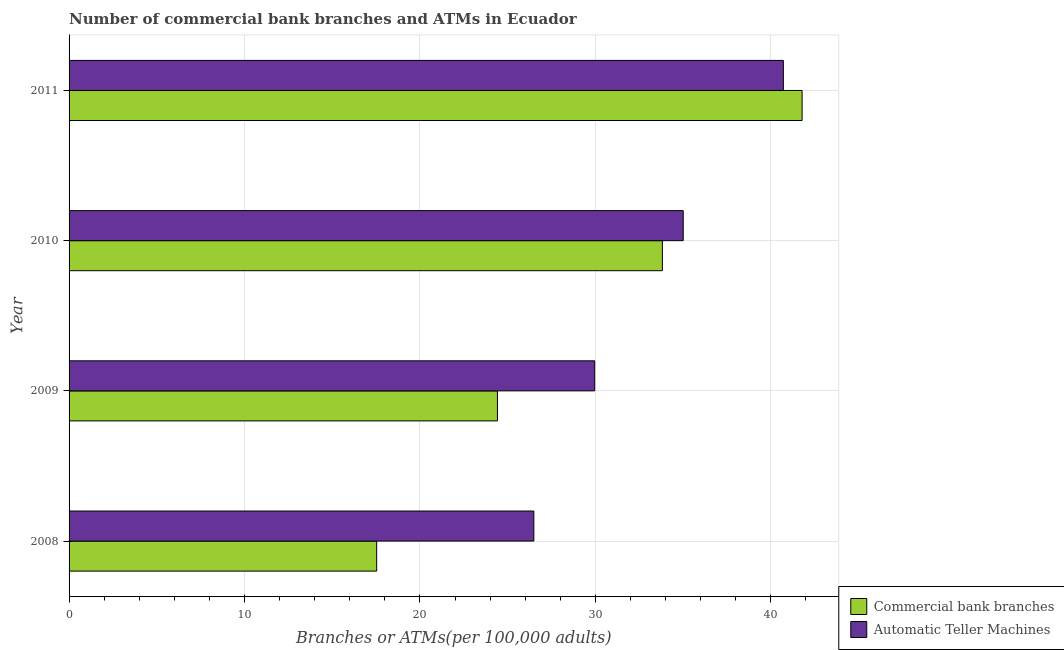How many different coloured bars are there?
Give a very brief answer. 2. How many groups of bars are there?
Provide a succinct answer. 4. Are the number of bars per tick equal to the number of legend labels?
Ensure brevity in your answer.  Yes. Are the number of bars on each tick of the Y-axis equal?
Offer a very short reply. Yes. How many bars are there on the 4th tick from the bottom?
Provide a short and direct response. 2. What is the label of the 1st group of bars from the top?
Provide a short and direct response. 2011. What is the number of atms in 2010?
Your answer should be very brief. 35.01. Across all years, what is the maximum number of atms?
Keep it short and to the point. 40.72. Across all years, what is the minimum number of commercal bank branches?
Keep it short and to the point. 17.53. What is the total number of commercal bank branches in the graph?
Your response must be concise. 117.56. What is the difference between the number of atms in 2009 and that in 2010?
Provide a succinct answer. -5.05. What is the difference between the number of atms in 2010 and the number of commercal bank branches in 2009?
Ensure brevity in your answer.  10.59. What is the average number of commercal bank branches per year?
Provide a short and direct response. 29.39. In the year 2010, what is the difference between the number of atms and number of commercal bank branches?
Your answer should be very brief. 1.19. What is the ratio of the number of atms in 2010 to that in 2011?
Offer a terse response. 0.86. Is the difference between the number of commercal bank branches in 2008 and 2011 greater than the difference between the number of atms in 2008 and 2011?
Your response must be concise. No. What is the difference between the highest and the second highest number of atms?
Your answer should be compact. 5.71. What is the difference between the highest and the lowest number of atms?
Provide a succinct answer. 14.22. In how many years, is the number of commercal bank branches greater than the average number of commercal bank branches taken over all years?
Your answer should be compact. 2. What does the 1st bar from the top in 2010 represents?
Your answer should be compact. Automatic Teller Machines. What does the 2nd bar from the bottom in 2011 represents?
Offer a very short reply. Automatic Teller Machines. How many bars are there?
Give a very brief answer. 8. Are all the bars in the graph horizontal?
Your answer should be compact. Yes. Are the values on the major ticks of X-axis written in scientific E-notation?
Provide a short and direct response. No. How many legend labels are there?
Give a very brief answer. 2. How are the legend labels stacked?
Offer a terse response. Vertical. What is the title of the graph?
Ensure brevity in your answer.  Number of commercial bank branches and ATMs in Ecuador. What is the label or title of the X-axis?
Ensure brevity in your answer.  Branches or ATMs(per 100,0 adults). What is the Branches or ATMs(per 100,000 adults) of Commercial bank branches in 2008?
Give a very brief answer. 17.53. What is the Branches or ATMs(per 100,000 adults) of Automatic Teller Machines in 2008?
Ensure brevity in your answer.  26.49. What is the Branches or ATMs(per 100,000 adults) of Commercial bank branches in 2009?
Provide a succinct answer. 24.42. What is the Branches or ATMs(per 100,000 adults) of Automatic Teller Machines in 2009?
Offer a terse response. 29.96. What is the Branches or ATMs(per 100,000 adults) of Commercial bank branches in 2010?
Your answer should be compact. 33.82. What is the Branches or ATMs(per 100,000 adults) in Automatic Teller Machines in 2010?
Your answer should be very brief. 35.01. What is the Branches or ATMs(per 100,000 adults) of Commercial bank branches in 2011?
Your answer should be compact. 41.78. What is the Branches or ATMs(per 100,000 adults) in Automatic Teller Machines in 2011?
Your answer should be compact. 40.72. Across all years, what is the maximum Branches or ATMs(per 100,000 adults) in Commercial bank branches?
Keep it short and to the point. 41.78. Across all years, what is the maximum Branches or ATMs(per 100,000 adults) of Automatic Teller Machines?
Offer a very short reply. 40.72. Across all years, what is the minimum Branches or ATMs(per 100,000 adults) in Commercial bank branches?
Your answer should be compact. 17.53. Across all years, what is the minimum Branches or ATMs(per 100,000 adults) in Automatic Teller Machines?
Offer a very short reply. 26.49. What is the total Branches or ATMs(per 100,000 adults) in Commercial bank branches in the graph?
Make the answer very short. 117.56. What is the total Branches or ATMs(per 100,000 adults) of Automatic Teller Machines in the graph?
Your answer should be compact. 132.18. What is the difference between the Branches or ATMs(per 100,000 adults) of Commercial bank branches in 2008 and that in 2009?
Offer a very short reply. -6.88. What is the difference between the Branches or ATMs(per 100,000 adults) of Automatic Teller Machines in 2008 and that in 2009?
Your answer should be compact. -3.47. What is the difference between the Branches or ATMs(per 100,000 adults) of Commercial bank branches in 2008 and that in 2010?
Make the answer very short. -16.29. What is the difference between the Branches or ATMs(per 100,000 adults) of Automatic Teller Machines in 2008 and that in 2010?
Your answer should be very brief. -8.51. What is the difference between the Branches or ATMs(per 100,000 adults) in Commercial bank branches in 2008 and that in 2011?
Provide a succinct answer. -24.25. What is the difference between the Branches or ATMs(per 100,000 adults) of Automatic Teller Machines in 2008 and that in 2011?
Your response must be concise. -14.22. What is the difference between the Branches or ATMs(per 100,000 adults) of Commercial bank branches in 2009 and that in 2010?
Your answer should be very brief. -9.4. What is the difference between the Branches or ATMs(per 100,000 adults) of Automatic Teller Machines in 2009 and that in 2010?
Provide a short and direct response. -5.05. What is the difference between the Branches or ATMs(per 100,000 adults) of Commercial bank branches in 2009 and that in 2011?
Keep it short and to the point. -17.37. What is the difference between the Branches or ATMs(per 100,000 adults) of Automatic Teller Machines in 2009 and that in 2011?
Keep it short and to the point. -10.75. What is the difference between the Branches or ATMs(per 100,000 adults) in Commercial bank branches in 2010 and that in 2011?
Your answer should be compact. -7.96. What is the difference between the Branches or ATMs(per 100,000 adults) of Automatic Teller Machines in 2010 and that in 2011?
Make the answer very short. -5.71. What is the difference between the Branches or ATMs(per 100,000 adults) of Commercial bank branches in 2008 and the Branches or ATMs(per 100,000 adults) of Automatic Teller Machines in 2009?
Make the answer very short. -12.43. What is the difference between the Branches or ATMs(per 100,000 adults) of Commercial bank branches in 2008 and the Branches or ATMs(per 100,000 adults) of Automatic Teller Machines in 2010?
Provide a succinct answer. -17.47. What is the difference between the Branches or ATMs(per 100,000 adults) of Commercial bank branches in 2008 and the Branches or ATMs(per 100,000 adults) of Automatic Teller Machines in 2011?
Your response must be concise. -23.18. What is the difference between the Branches or ATMs(per 100,000 adults) of Commercial bank branches in 2009 and the Branches or ATMs(per 100,000 adults) of Automatic Teller Machines in 2010?
Your answer should be very brief. -10.59. What is the difference between the Branches or ATMs(per 100,000 adults) of Commercial bank branches in 2009 and the Branches or ATMs(per 100,000 adults) of Automatic Teller Machines in 2011?
Provide a succinct answer. -16.3. What is the difference between the Branches or ATMs(per 100,000 adults) in Commercial bank branches in 2010 and the Branches or ATMs(per 100,000 adults) in Automatic Teller Machines in 2011?
Keep it short and to the point. -6.9. What is the average Branches or ATMs(per 100,000 adults) of Commercial bank branches per year?
Your response must be concise. 29.39. What is the average Branches or ATMs(per 100,000 adults) in Automatic Teller Machines per year?
Provide a short and direct response. 33.04. In the year 2008, what is the difference between the Branches or ATMs(per 100,000 adults) of Commercial bank branches and Branches or ATMs(per 100,000 adults) of Automatic Teller Machines?
Your answer should be very brief. -8.96. In the year 2009, what is the difference between the Branches or ATMs(per 100,000 adults) in Commercial bank branches and Branches or ATMs(per 100,000 adults) in Automatic Teller Machines?
Your answer should be very brief. -5.54. In the year 2010, what is the difference between the Branches or ATMs(per 100,000 adults) in Commercial bank branches and Branches or ATMs(per 100,000 adults) in Automatic Teller Machines?
Your response must be concise. -1.19. In the year 2011, what is the difference between the Branches or ATMs(per 100,000 adults) of Commercial bank branches and Branches or ATMs(per 100,000 adults) of Automatic Teller Machines?
Ensure brevity in your answer.  1.07. What is the ratio of the Branches or ATMs(per 100,000 adults) in Commercial bank branches in 2008 to that in 2009?
Your answer should be very brief. 0.72. What is the ratio of the Branches or ATMs(per 100,000 adults) of Automatic Teller Machines in 2008 to that in 2009?
Provide a succinct answer. 0.88. What is the ratio of the Branches or ATMs(per 100,000 adults) in Commercial bank branches in 2008 to that in 2010?
Keep it short and to the point. 0.52. What is the ratio of the Branches or ATMs(per 100,000 adults) of Automatic Teller Machines in 2008 to that in 2010?
Your answer should be very brief. 0.76. What is the ratio of the Branches or ATMs(per 100,000 adults) of Commercial bank branches in 2008 to that in 2011?
Your response must be concise. 0.42. What is the ratio of the Branches or ATMs(per 100,000 adults) of Automatic Teller Machines in 2008 to that in 2011?
Ensure brevity in your answer.  0.65. What is the ratio of the Branches or ATMs(per 100,000 adults) of Commercial bank branches in 2009 to that in 2010?
Give a very brief answer. 0.72. What is the ratio of the Branches or ATMs(per 100,000 adults) of Automatic Teller Machines in 2009 to that in 2010?
Give a very brief answer. 0.86. What is the ratio of the Branches or ATMs(per 100,000 adults) of Commercial bank branches in 2009 to that in 2011?
Offer a very short reply. 0.58. What is the ratio of the Branches or ATMs(per 100,000 adults) of Automatic Teller Machines in 2009 to that in 2011?
Your response must be concise. 0.74. What is the ratio of the Branches or ATMs(per 100,000 adults) of Commercial bank branches in 2010 to that in 2011?
Offer a very short reply. 0.81. What is the ratio of the Branches or ATMs(per 100,000 adults) of Automatic Teller Machines in 2010 to that in 2011?
Your answer should be compact. 0.86. What is the difference between the highest and the second highest Branches or ATMs(per 100,000 adults) in Commercial bank branches?
Provide a succinct answer. 7.96. What is the difference between the highest and the second highest Branches or ATMs(per 100,000 adults) of Automatic Teller Machines?
Your answer should be compact. 5.71. What is the difference between the highest and the lowest Branches or ATMs(per 100,000 adults) in Commercial bank branches?
Provide a short and direct response. 24.25. What is the difference between the highest and the lowest Branches or ATMs(per 100,000 adults) of Automatic Teller Machines?
Give a very brief answer. 14.22. 